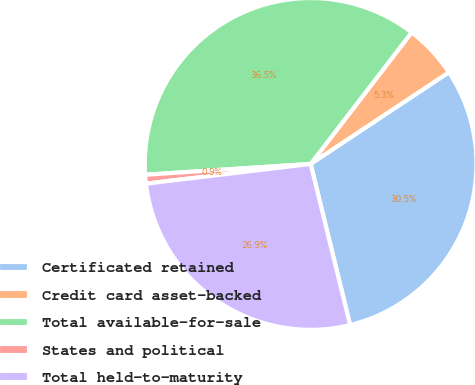Convert chart. <chart><loc_0><loc_0><loc_500><loc_500><pie_chart><fcel>Certificated retained<fcel>Credit card asset-backed<fcel>Total available-for-sale<fcel>States and political<fcel>Total held-to-maturity<nl><fcel>30.49%<fcel>5.26%<fcel>36.46%<fcel>0.86%<fcel>26.93%<nl></chart> 